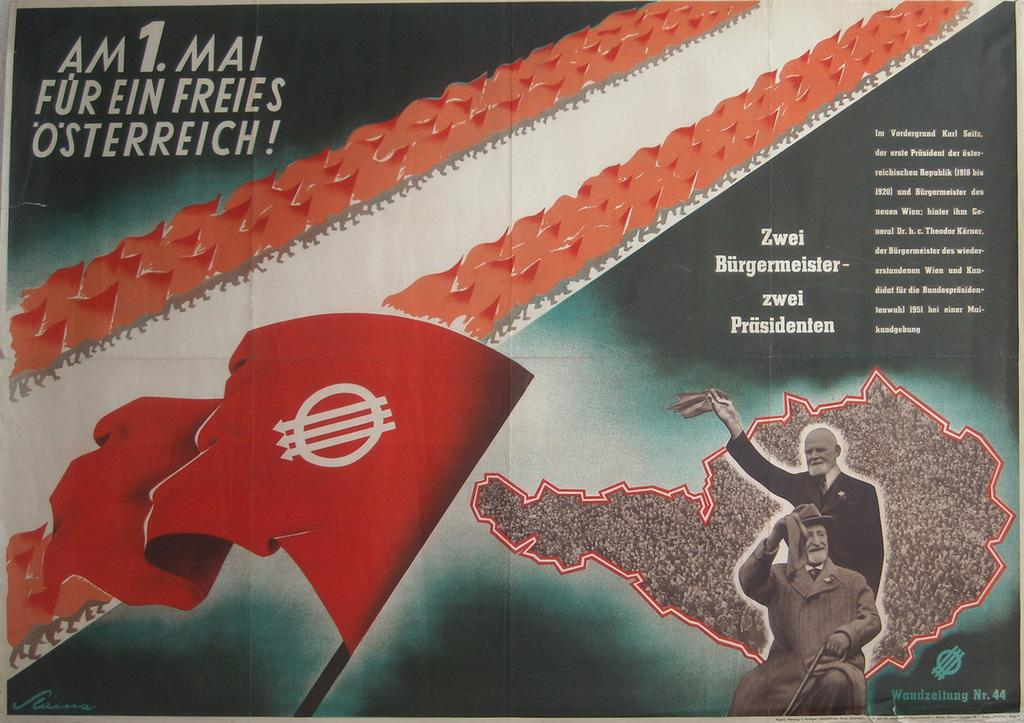<image>
Offer a succinct explanation of the picture presented. Poster showing two men and a flag and says "Am 1. Mai Fur Ein Freies Osterreich!". 